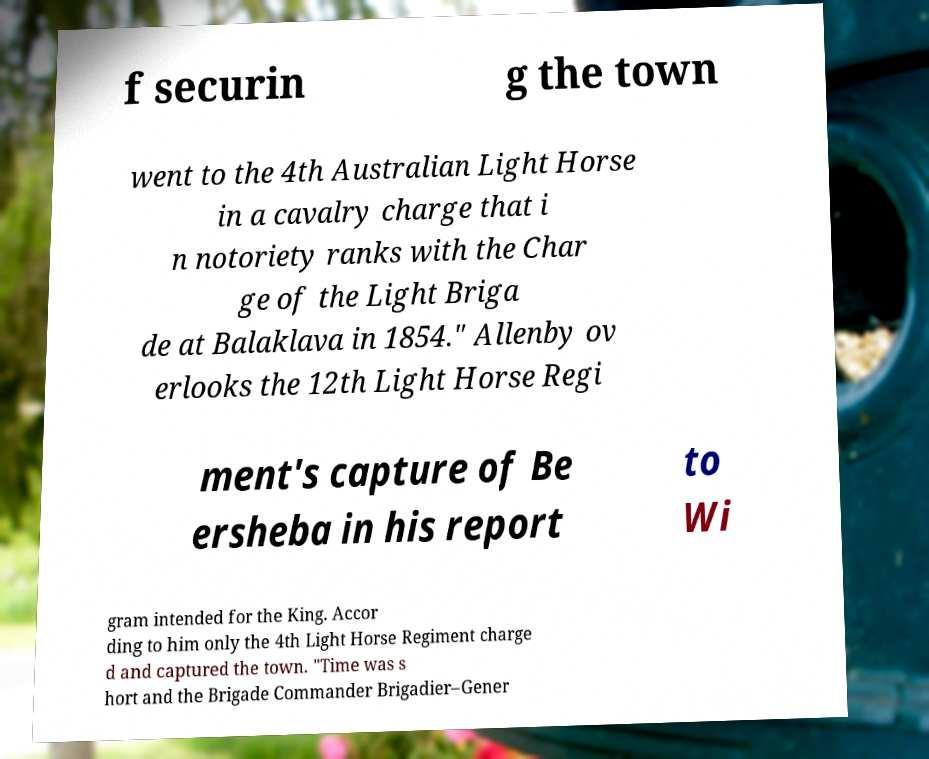Can you accurately transcribe the text from the provided image for me? f securin g the town went to the 4th Australian Light Horse in a cavalry charge that i n notoriety ranks with the Char ge of the Light Briga de at Balaklava in 1854." Allenby ov erlooks the 12th Light Horse Regi ment's capture of Be ersheba in his report to Wi gram intended for the King. Accor ding to him only the 4th Light Horse Regiment charge d and captured the town. "Time was s hort and the Brigade Commander Brigadier–Gener 